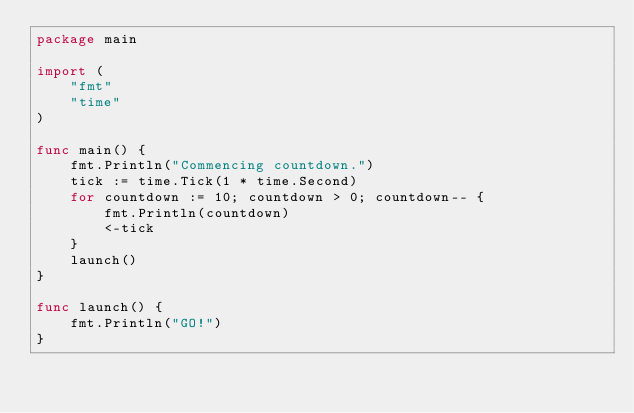<code> <loc_0><loc_0><loc_500><loc_500><_Go_>package main

import (
	"fmt"
	"time"
)

func main() {
	fmt.Println("Commencing countdown.")
	tick := time.Tick(1 * time.Second)
	for countdown := 10; countdown > 0; countdown-- {
		fmt.Println(countdown)
		<-tick
	}
	launch()
}

func launch() {
	fmt.Println("GO!")
}
</code> 